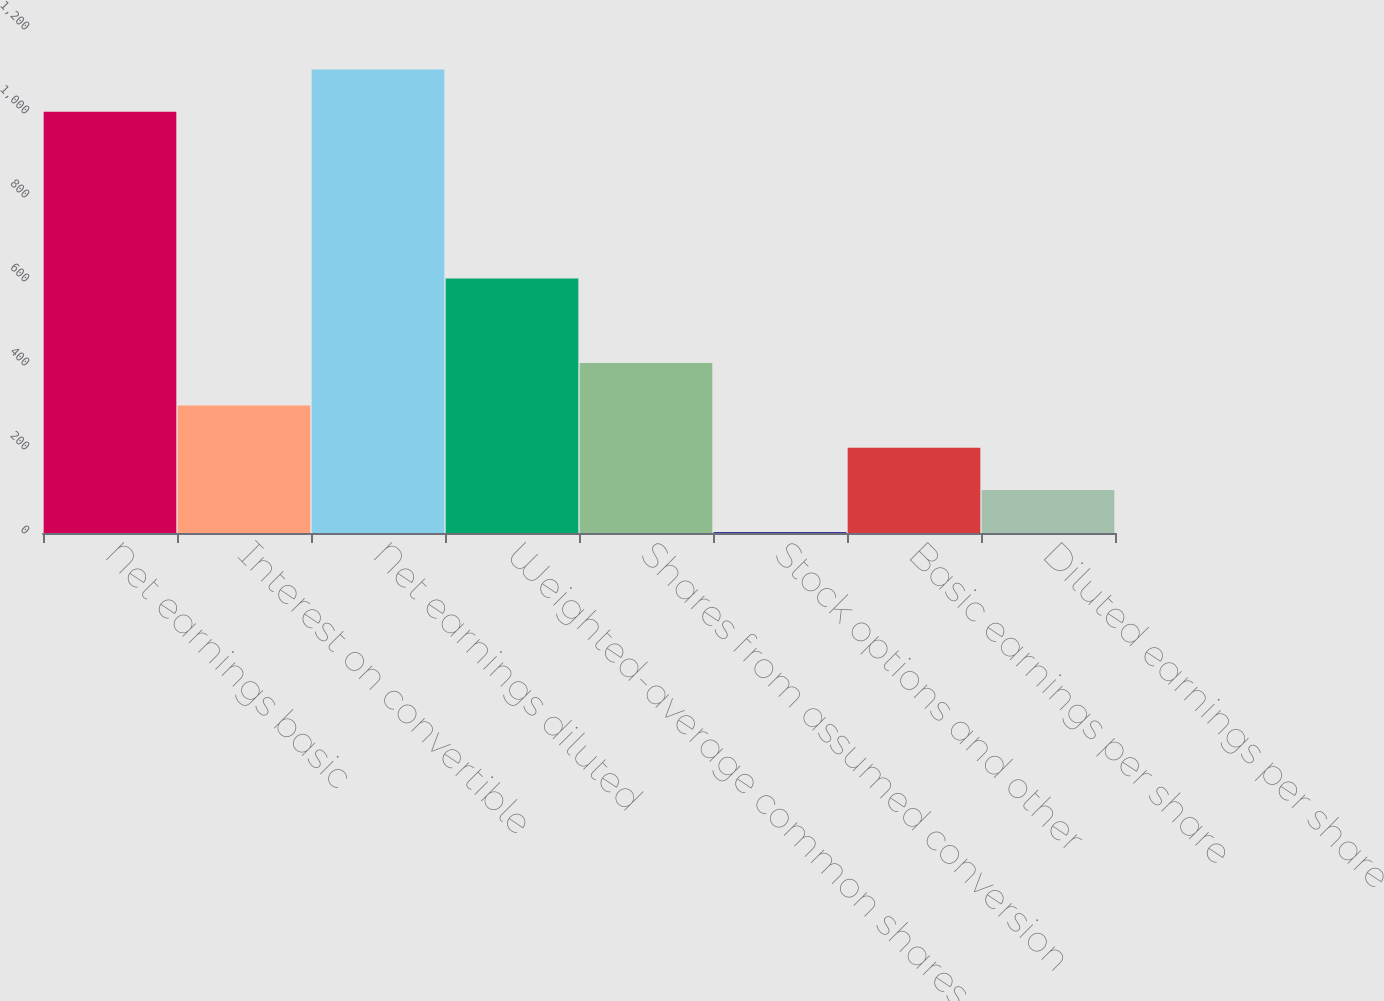Convert chart. <chart><loc_0><loc_0><loc_500><loc_500><bar_chart><fcel>Net earnings basic<fcel>Interest on convertible<fcel>Net earnings diluted<fcel>Weighted-average common shares<fcel>Shares from assumed conversion<fcel>Stock options and other<fcel>Basic earnings per share<fcel>Diluted earnings per share<nl><fcel>1003<fcel>303.82<fcel>1103.74<fcel>606.04<fcel>404.56<fcel>1.6<fcel>203.08<fcel>102.34<nl></chart> 